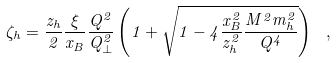<formula> <loc_0><loc_0><loc_500><loc_500>\zeta _ { h } = \frac { z _ { h } } { 2 } \frac { \xi } { x _ { B } } \frac { Q ^ { 2 } } { Q _ { \perp } ^ { 2 } } \left ( 1 + \sqrt { 1 - 4 \frac { x _ { B } ^ { 2 } } { z _ { h } ^ { 2 } } \frac { M ^ { 2 } m _ { h } ^ { 2 } } { Q ^ { 4 } } } \right ) \ ,</formula> 